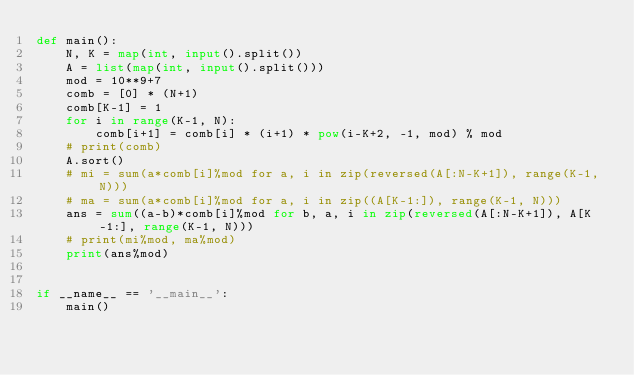Convert code to text. <code><loc_0><loc_0><loc_500><loc_500><_Python_>def main():
    N, K = map(int, input().split())
    A = list(map(int, input().split()))
    mod = 10**9+7
    comb = [0] * (N+1)
    comb[K-1] = 1
    for i in range(K-1, N):
        comb[i+1] = comb[i] * (i+1) * pow(i-K+2, -1, mod) % mod
    # print(comb)
    A.sort()
    # mi = sum(a*comb[i]%mod for a, i in zip(reversed(A[:N-K+1]), range(K-1, N)))
    # ma = sum(a*comb[i]%mod for a, i in zip((A[K-1:]), range(K-1, N)))
    ans = sum((a-b)*comb[i]%mod for b, a, i in zip(reversed(A[:N-K+1]), A[K-1:], range(K-1, N)))
    # print(mi%mod, ma%mod)
    print(ans%mod)


if __name__ == '__main__':
    main()</code> 